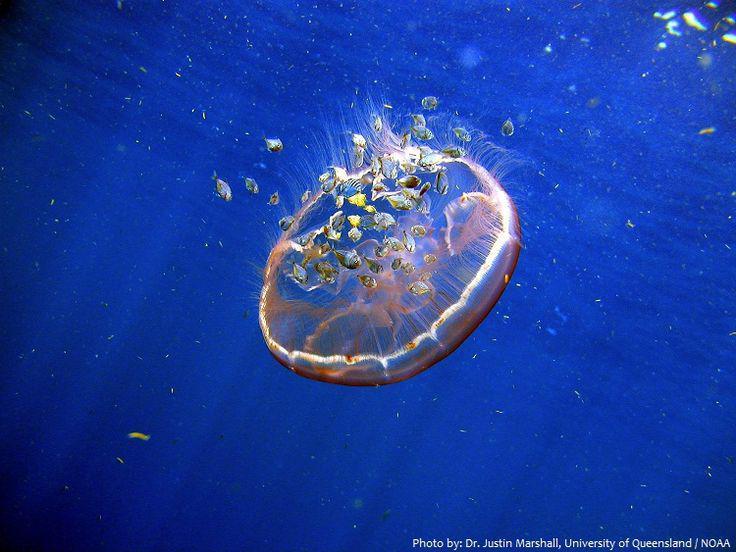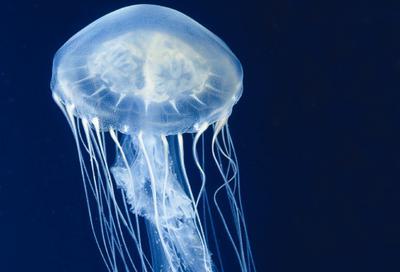The first image is the image on the left, the second image is the image on the right. For the images shown, is this caption "There are multiple jellyfish in the image on the left." true? Answer yes or no. No. The first image is the image on the left, the second image is the image on the right. Analyze the images presented: Is the assertion "All jellyfish have translucent glowing bluish bodies, and all trail slender tendrils." valid? Answer yes or no. No. 